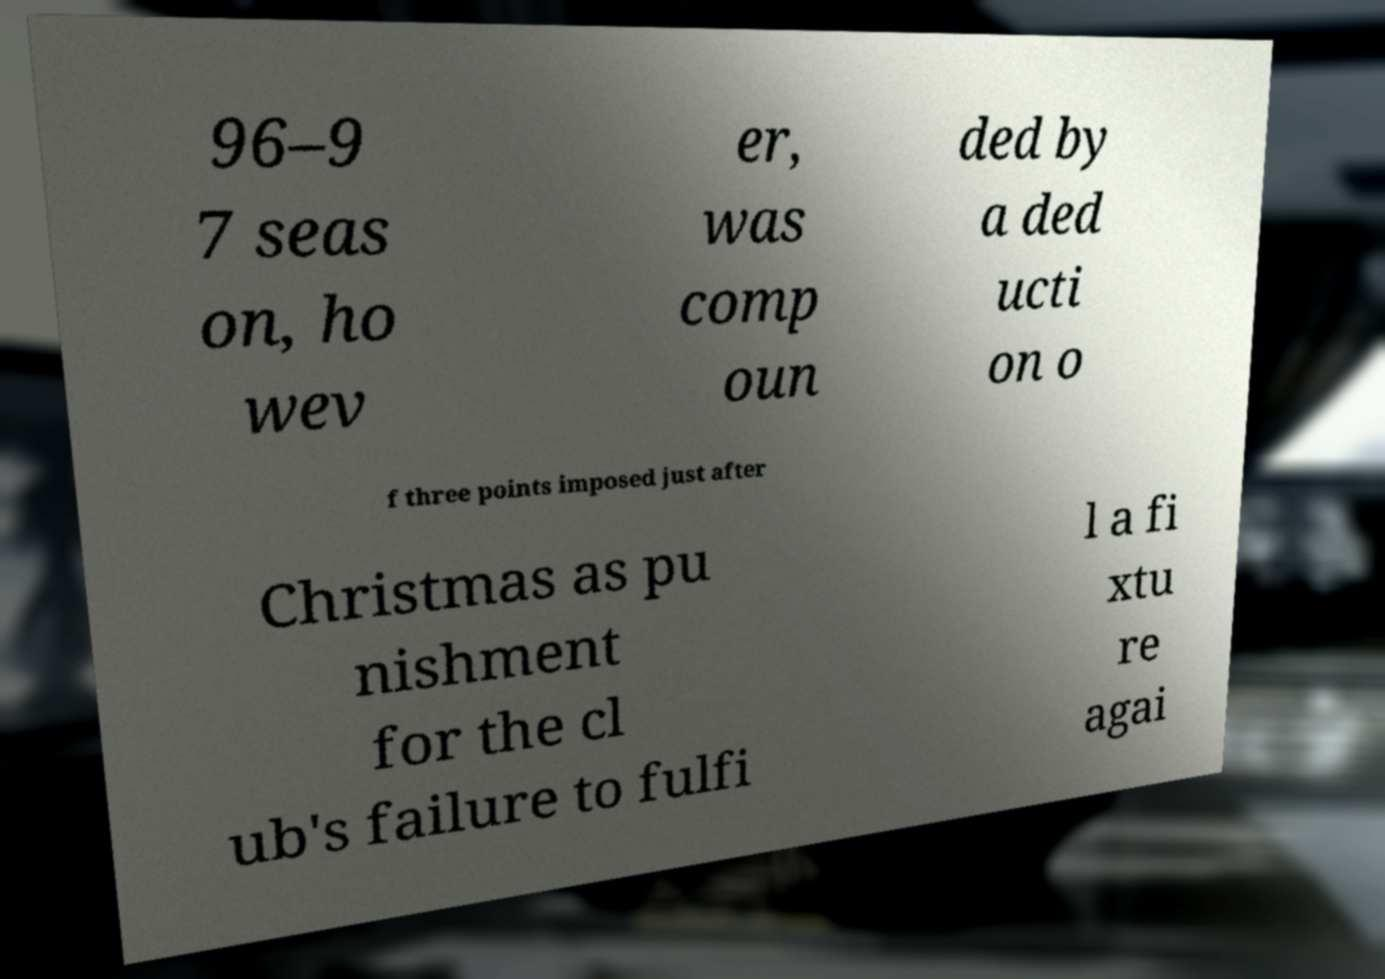There's text embedded in this image that I need extracted. Can you transcribe it verbatim? 96–9 7 seas on, ho wev er, was comp oun ded by a ded ucti on o f three points imposed just after Christmas as pu nishment for the cl ub's failure to fulfi l a fi xtu re agai 